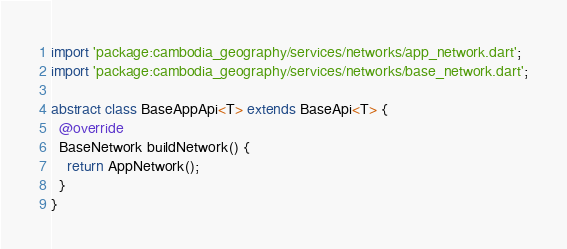Convert code to text. <code><loc_0><loc_0><loc_500><loc_500><_Dart_>import 'package:cambodia_geography/services/networks/app_network.dart';
import 'package:cambodia_geography/services/networks/base_network.dart';

abstract class BaseAppApi<T> extends BaseApi<T> {
  @override
  BaseNetwork buildNetwork() {
    return AppNetwork();
  }
}
</code> 